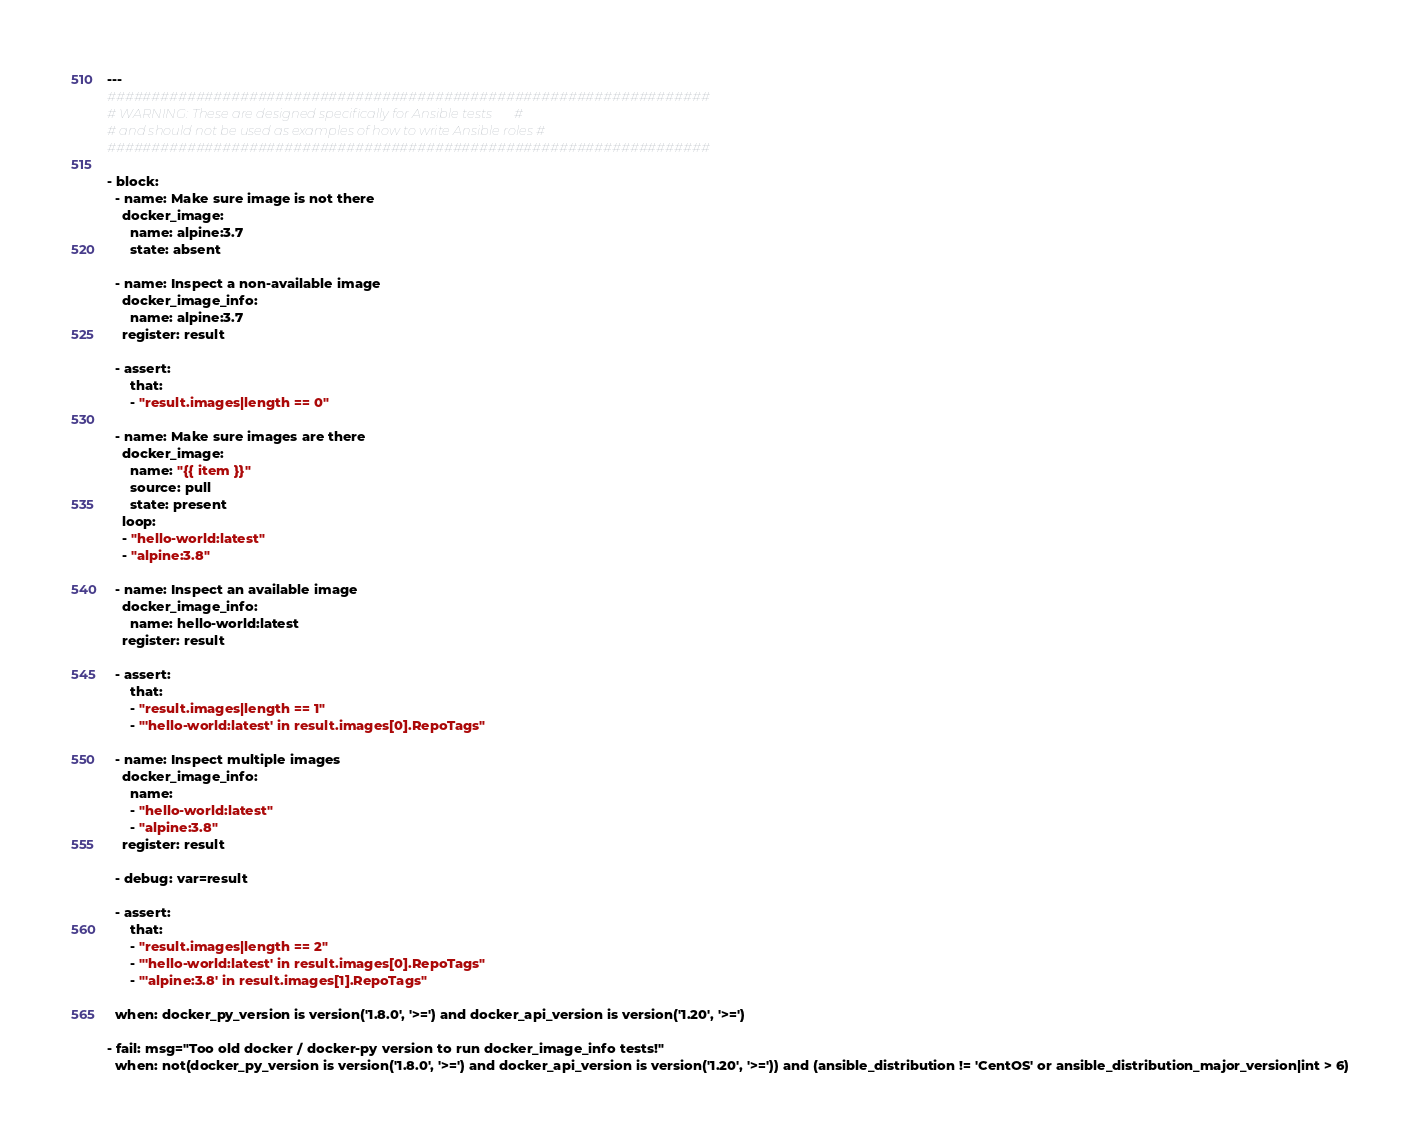<code> <loc_0><loc_0><loc_500><loc_500><_YAML_>---
####################################################################
# WARNING: These are designed specifically for Ansible tests       #
# and should not be used as examples of how to write Ansible roles #
####################################################################

- block:
  - name: Make sure image is not there
    docker_image:
      name: alpine:3.7
      state: absent

  - name: Inspect a non-available image
    docker_image_info:
      name: alpine:3.7
    register: result

  - assert:
      that:
      - "result.images|length == 0"

  - name: Make sure images are there
    docker_image:
      name: "{{ item }}"
      source: pull
      state: present
    loop:
    - "hello-world:latest"
    - "alpine:3.8"

  - name: Inspect an available image
    docker_image_info:
      name: hello-world:latest
    register: result

  - assert:
      that:
      - "result.images|length == 1"
      - "'hello-world:latest' in result.images[0].RepoTags"

  - name: Inspect multiple images
    docker_image_info:
      name:
      - "hello-world:latest"
      - "alpine:3.8"
    register: result

  - debug: var=result

  - assert:
      that:
      - "result.images|length == 2"
      - "'hello-world:latest' in result.images[0].RepoTags"
      - "'alpine:3.8' in result.images[1].RepoTags"

  when: docker_py_version is version('1.8.0', '>=') and docker_api_version is version('1.20', '>=')

- fail: msg="Too old docker / docker-py version to run docker_image_info tests!"
  when: not(docker_py_version is version('1.8.0', '>=') and docker_api_version is version('1.20', '>=')) and (ansible_distribution != 'CentOS' or ansible_distribution_major_version|int > 6)
</code> 